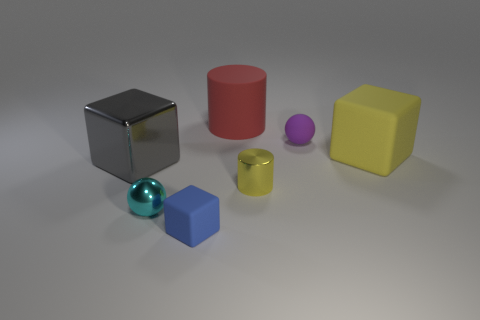Add 1 yellow matte cubes. How many objects exist? 8 Subtract all blocks. How many objects are left? 4 Add 7 purple matte cylinders. How many purple matte cylinders exist? 7 Subtract 0 cyan cylinders. How many objects are left? 7 Subtract all cylinders. Subtract all balls. How many objects are left? 3 Add 6 large gray things. How many large gray things are left? 7 